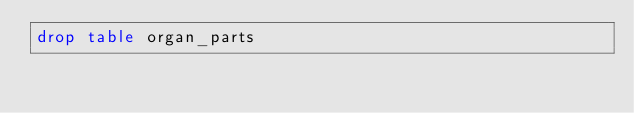<code> <loc_0><loc_0><loc_500><loc_500><_SQL_>drop table organ_parts</code> 